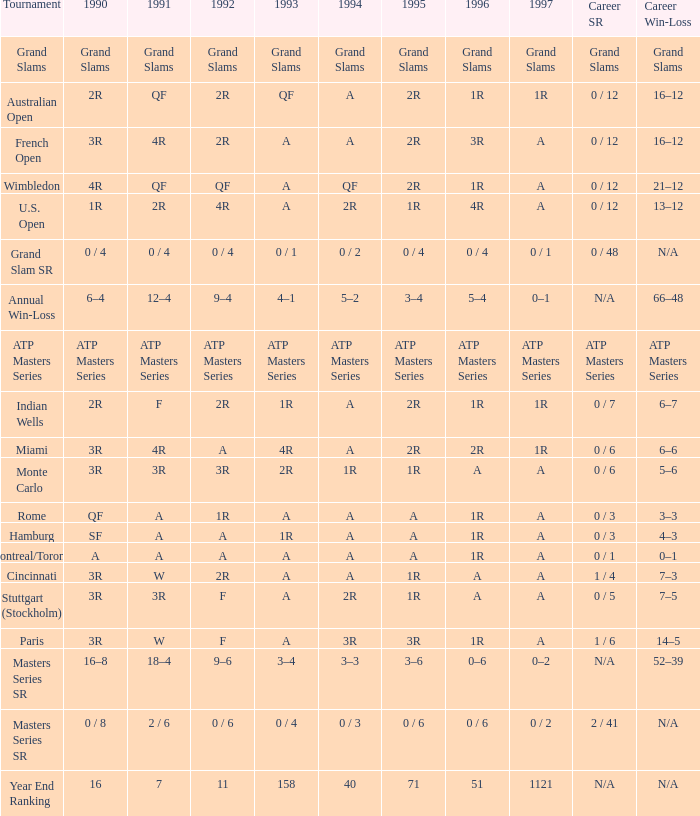What is 1995, when Tournament is "Miami"? 2R. Write the full table. {'header': ['Tournament', '1990', '1991', '1992', '1993', '1994', '1995', '1996', '1997', 'Career SR', 'Career Win-Loss'], 'rows': [['Grand Slams', 'Grand Slams', 'Grand Slams', 'Grand Slams', 'Grand Slams', 'Grand Slams', 'Grand Slams', 'Grand Slams', 'Grand Slams', 'Grand Slams', 'Grand Slams'], ['Australian Open', '2R', 'QF', '2R', 'QF', 'A', '2R', '1R', '1R', '0 / 12', '16–12'], ['French Open', '3R', '4R', '2R', 'A', 'A', '2R', '3R', 'A', '0 / 12', '16–12'], ['Wimbledon', '4R', 'QF', 'QF', 'A', 'QF', '2R', '1R', 'A', '0 / 12', '21–12'], ['U.S. Open', '1R', '2R', '4R', 'A', '2R', '1R', '4R', 'A', '0 / 12', '13–12'], ['Grand Slam SR', '0 / 4', '0 / 4', '0 / 4', '0 / 1', '0 / 2', '0 / 4', '0 / 4', '0 / 1', '0 / 48', 'N/A'], ['Annual Win-Loss', '6–4', '12–4', '9–4', '4–1', '5–2', '3–4', '5–4', '0–1', 'N/A', '66–48'], ['ATP Masters Series', 'ATP Masters Series', 'ATP Masters Series', 'ATP Masters Series', 'ATP Masters Series', 'ATP Masters Series', 'ATP Masters Series', 'ATP Masters Series', 'ATP Masters Series', 'ATP Masters Series', 'ATP Masters Series'], ['Indian Wells', '2R', 'F', '2R', '1R', 'A', '2R', '1R', '1R', '0 / 7', '6–7'], ['Miami', '3R', '4R', 'A', '4R', 'A', '2R', '2R', '1R', '0 / 6', '6–6'], ['Monte Carlo', '3R', '3R', '3R', '2R', '1R', '1R', 'A', 'A', '0 / 6', '5–6'], ['Rome', 'QF', 'A', '1R', 'A', 'A', 'A', '1R', 'A', '0 / 3', '3–3'], ['Hamburg', 'SF', 'A', 'A', '1R', 'A', 'A', '1R', 'A', '0 / 3', '4–3'], ['Montreal/Toronto', 'A', 'A', 'A', 'A', 'A', 'A', '1R', 'A', '0 / 1', '0–1'], ['Cincinnati', '3R', 'W', '2R', 'A', 'A', '1R', 'A', 'A', '1 / 4', '7–3'], ['Stuttgart (Stockholm)', '3R', '3R', 'F', 'A', '2R', '1R', 'A', 'A', '0 / 5', '7–5'], ['Paris', '3R', 'W', 'F', 'A', '3R', '3R', '1R', 'A', '1 / 6', '14–5'], ['Masters Series SR', '16–8', '18–4', '9–6', '3–4', '3–3', '3–6', '0–6', '0–2', 'N/A', '52–39'], ['Masters Series SR', '0 / 8', '2 / 6', '0 / 6', '0 / 4', '0 / 3', '0 / 6', '0 / 6', '0 / 2', '2 / 41', 'N/A'], ['Year End Ranking', '16', '7', '11', '158', '40', '71', '51', '1121', 'N/A', 'N/A']]} 